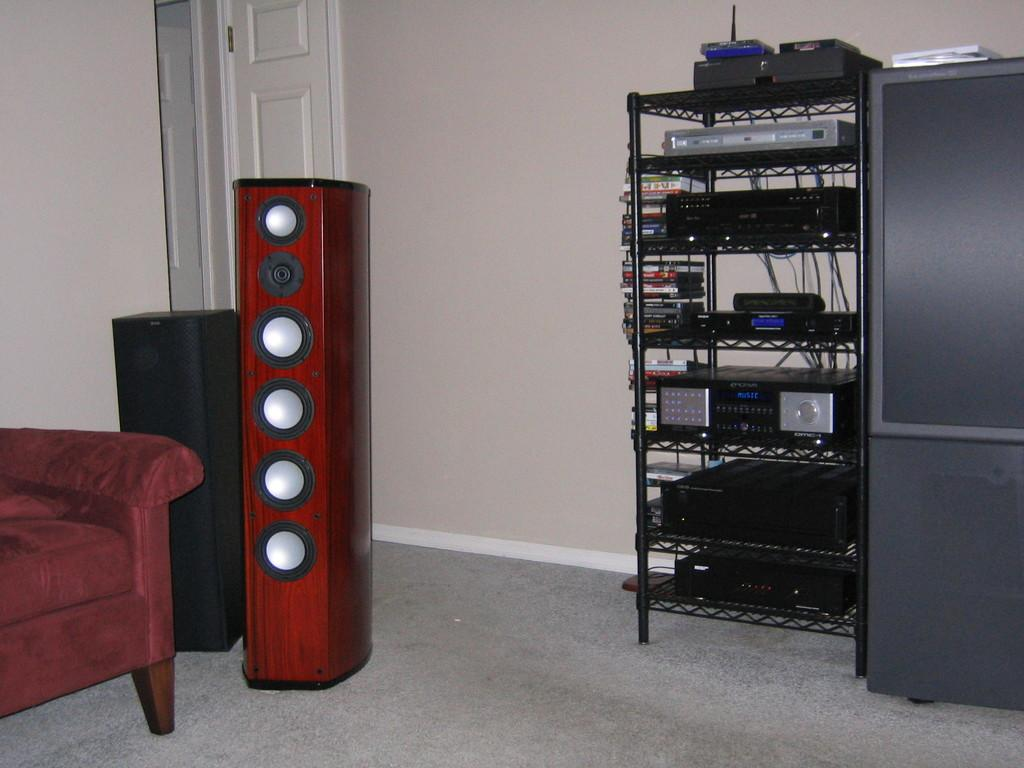What type of furniture is present in the image? There is a shelf and a couch in the image. What items can be found on the shelf? The shelf contains CDs, a recorder, and some electronics. What audio equipment is visible in the image? There are speakers in the image. What architectural feature is present in the image? There is a door in the image. Are there any other objects in the image besides the ones mentioned? Yes, there are additional objects in the image. What type of wealth is displayed on the shelf in the image? There is no wealth displayed on the shelf in the image; it contains CDs, a recorder, and some electronics. What substance is being used to create the metal objects in the image? There are no metal objects present in the image. 